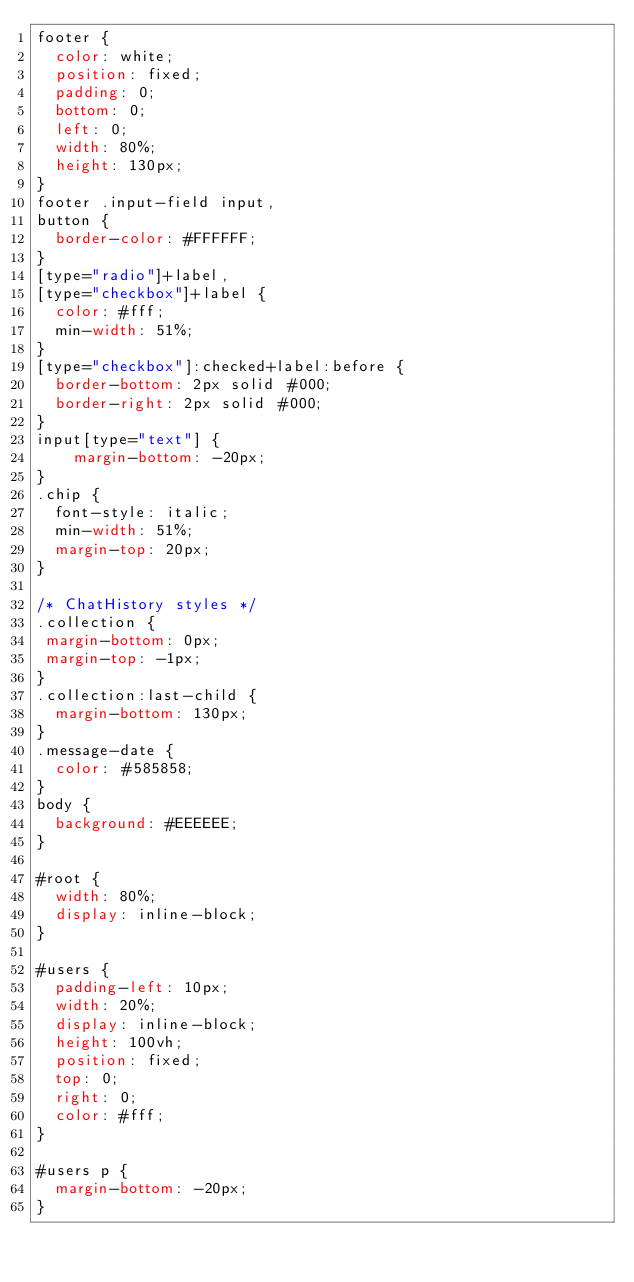<code> <loc_0><loc_0><loc_500><loc_500><_CSS_>footer {
  color: white;
  position: fixed;
  padding: 0;
  bottom: 0;
  left: 0;
  width: 80%;
  height: 130px;
}
footer .input-field input,
button {
  border-color: #FFFFFF;
}
[type="radio"]+label,
[type="checkbox"]+label {
  color: #fff;
  min-width: 51%;
}
[type="checkbox"]:checked+label:before {
  border-bottom: 2px solid #000;
  border-right: 2px solid #000;
}
input[type="text"] {
    margin-bottom: -20px;
}
.chip {
  font-style: italic;
  min-width: 51%;
  margin-top: 20px;
}

/* ChatHistory styles */
.collection {
 margin-bottom: 0px;
 margin-top: -1px;
}
.collection:last-child {
  margin-bottom: 130px;
}
.message-date {
  color: #585858;
}
body {
  background: #EEEEEE;
}

#root {
	width: 80%;
	display: inline-block;
}

#users {
	padding-left: 10px;
	width: 20%;
	display: inline-block;
	height: 100vh;
	position: fixed;
	top: 0;
	right: 0;
	color: #fff;
}

#users p {
  margin-bottom: -20px;
}

</code> 